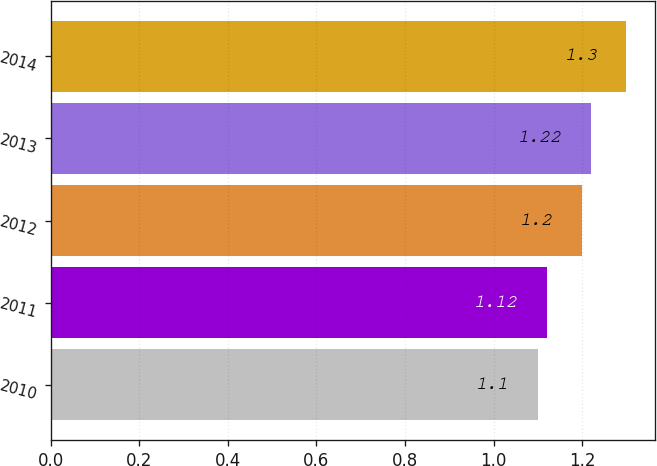Convert chart. <chart><loc_0><loc_0><loc_500><loc_500><bar_chart><fcel>2010<fcel>2011<fcel>2012<fcel>2013<fcel>2014<nl><fcel>1.1<fcel>1.12<fcel>1.2<fcel>1.22<fcel>1.3<nl></chart> 